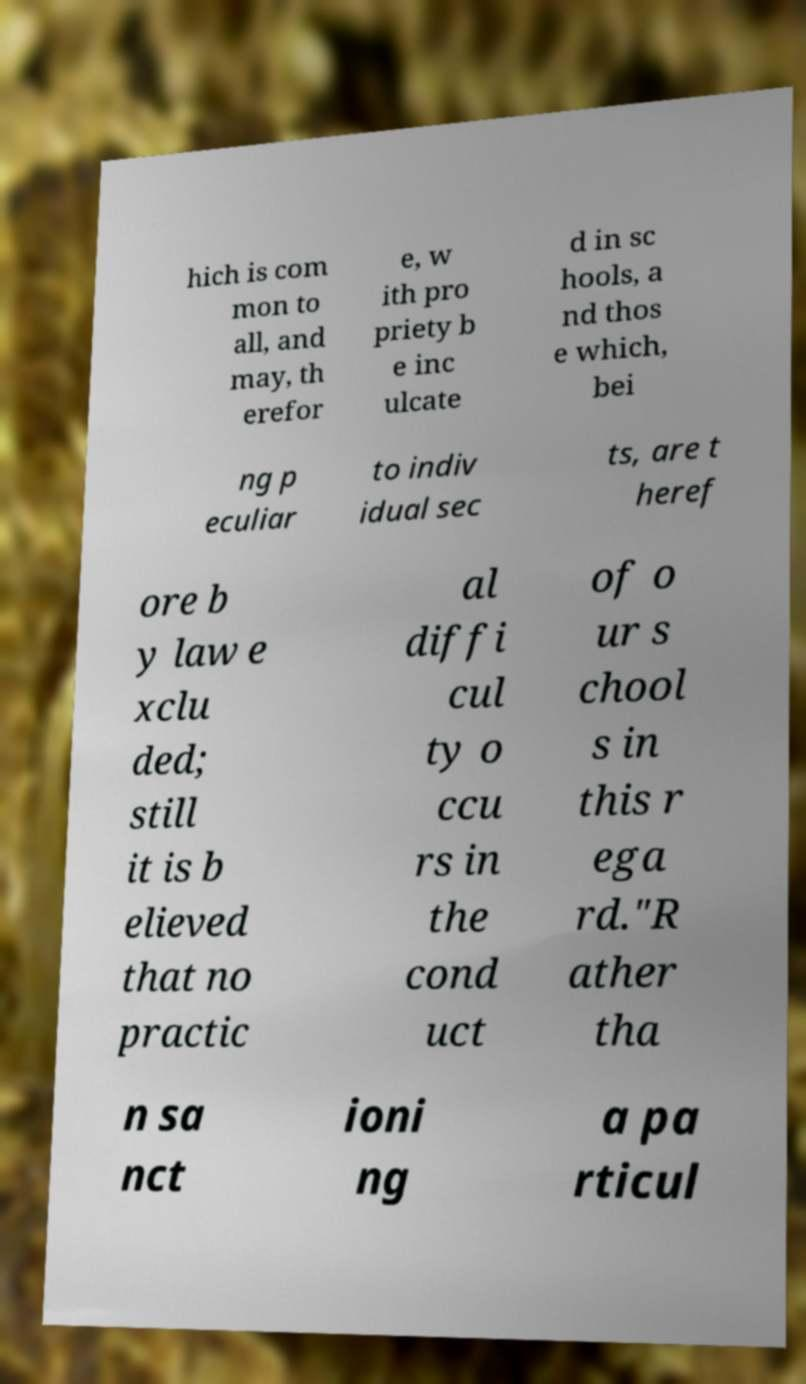I need the written content from this picture converted into text. Can you do that? hich is com mon to all, and may, th erefor e, w ith pro priety b e inc ulcate d in sc hools, a nd thos e which, bei ng p eculiar to indiv idual sec ts, are t heref ore b y law e xclu ded; still it is b elieved that no practic al diffi cul ty o ccu rs in the cond uct of o ur s chool s in this r ega rd."R ather tha n sa nct ioni ng a pa rticul 